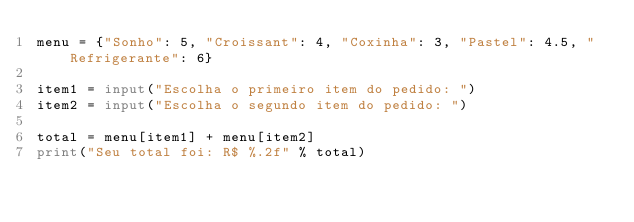<code> <loc_0><loc_0><loc_500><loc_500><_Python_>menu = {"Sonho": 5, "Croissant": 4, "Coxinha": 3, "Pastel": 4.5, "Refrigerante": 6}

item1 = input("Escolha o primeiro item do pedido: ")
item2 = input("Escolha o segundo item do pedido: ")

total = menu[item1] + menu[item2]
print("Seu total foi: R$ %.2f" % total)</code> 